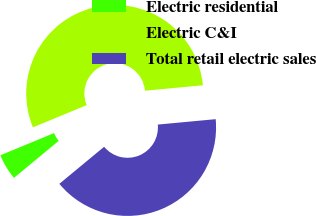Convert chart to OTSL. <chart><loc_0><loc_0><loc_500><loc_500><pie_chart><fcel>Electric residential<fcel>Electric C&I<fcel>Total retail electric sales<nl><fcel>4.76%<fcel>54.76%<fcel>40.48%<nl></chart> 